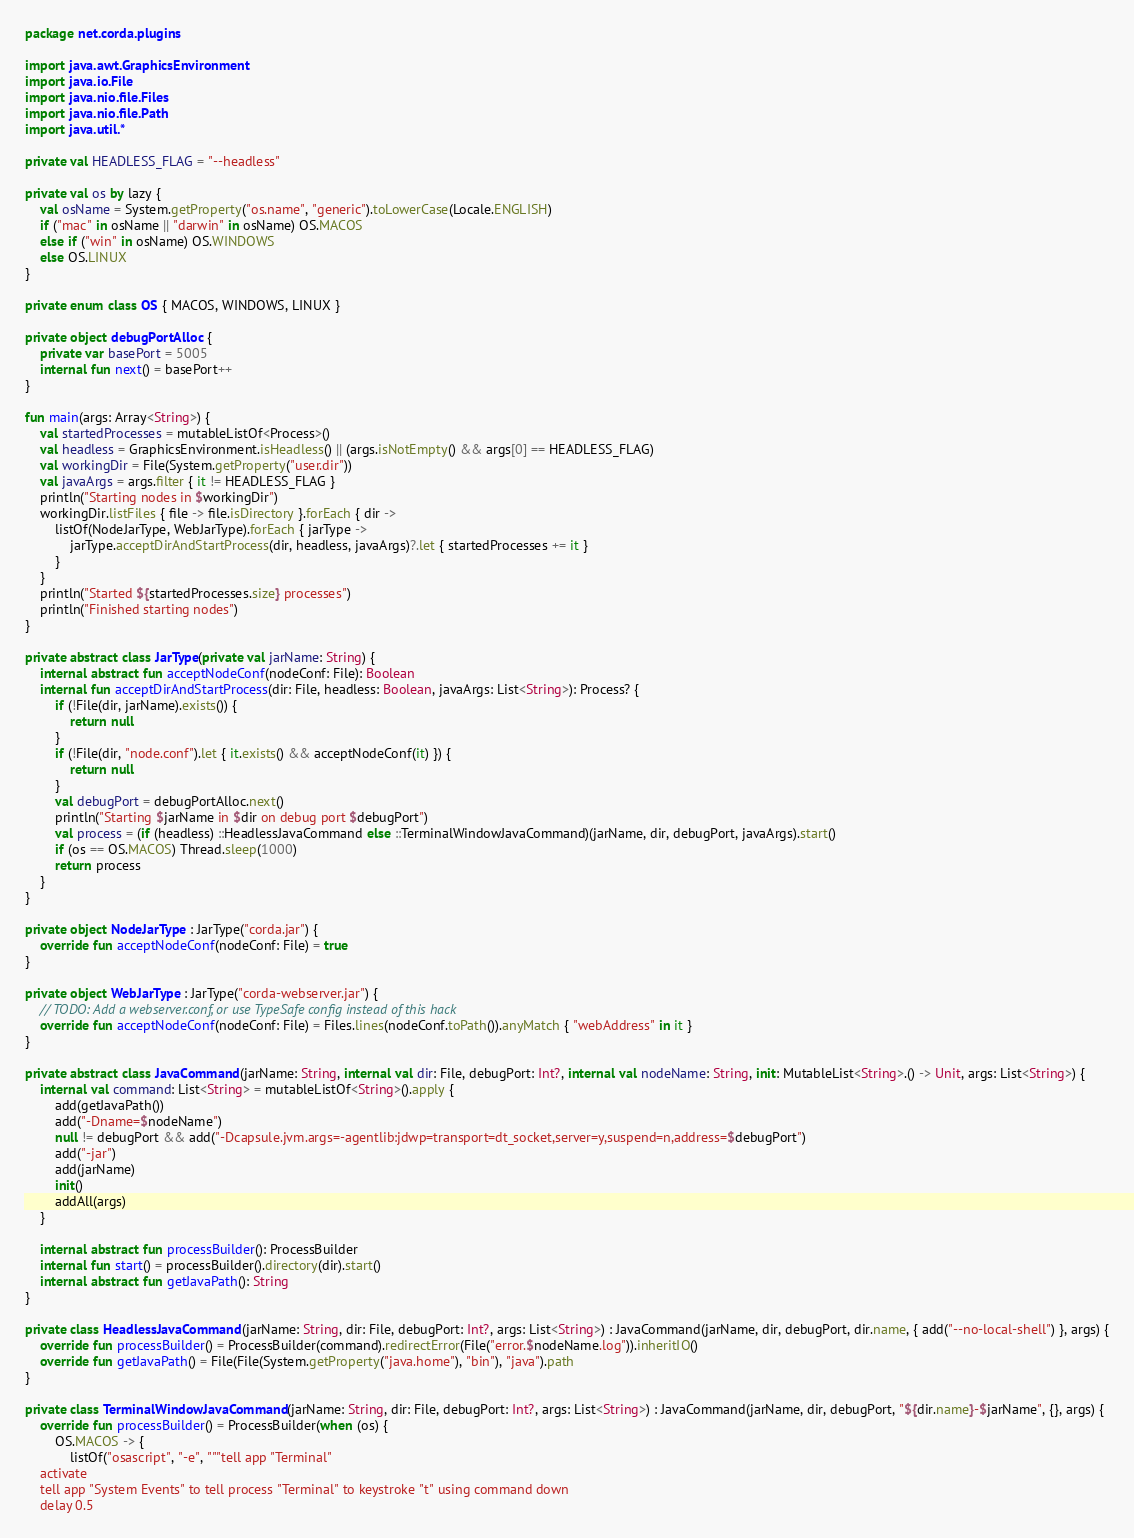<code> <loc_0><loc_0><loc_500><loc_500><_Kotlin_>package net.corda.plugins

import java.awt.GraphicsEnvironment
import java.io.File
import java.nio.file.Files
import java.nio.file.Path
import java.util.*

private val HEADLESS_FLAG = "--headless"

private val os by lazy {
    val osName = System.getProperty("os.name", "generic").toLowerCase(Locale.ENGLISH)
    if ("mac" in osName || "darwin" in osName) OS.MACOS
    else if ("win" in osName) OS.WINDOWS
    else OS.LINUX
}

private enum class OS { MACOS, WINDOWS, LINUX }

private object debugPortAlloc {
    private var basePort = 5005
    internal fun next() = basePort++
}

fun main(args: Array<String>) {
    val startedProcesses = mutableListOf<Process>()
    val headless = GraphicsEnvironment.isHeadless() || (args.isNotEmpty() && args[0] == HEADLESS_FLAG)
    val workingDir = File(System.getProperty("user.dir"))
    val javaArgs = args.filter { it != HEADLESS_FLAG }
    println("Starting nodes in $workingDir")
    workingDir.listFiles { file -> file.isDirectory }.forEach { dir ->
        listOf(NodeJarType, WebJarType).forEach { jarType ->
            jarType.acceptDirAndStartProcess(dir, headless, javaArgs)?.let { startedProcesses += it }
        }
    }
    println("Started ${startedProcesses.size} processes")
    println("Finished starting nodes")
}

private abstract class JarType(private val jarName: String) {
    internal abstract fun acceptNodeConf(nodeConf: File): Boolean
    internal fun acceptDirAndStartProcess(dir: File, headless: Boolean, javaArgs: List<String>): Process? {
        if (!File(dir, jarName).exists()) {
            return null
        }
        if (!File(dir, "node.conf").let { it.exists() && acceptNodeConf(it) }) {
            return null
        }
        val debugPort = debugPortAlloc.next()
        println("Starting $jarName in $dir on debug port $debugPort")
        val process = (if (headless) ::HeadlessJavaCommand else ::TerminalWindowJavaCommand)(jarName, dir, debugPort, javaArgs).start()
        if (os == OS.MACOS) Thread.sleep(1000)
        return process
    }
}

private object NodeJarType : JarType("corda.jar") {
    override fun acceptNodeConf(nodeConf: File) = true
}

private object WebJarType : JarType("corda-webserver.jar") {
    // TODO: Add a webserver.conf, or use TypeSafe config instead of this hack
    override fun acceptNodeConf(nodeConf: File) = Files.lines(nodeConf.toPath()).anyMatch { "webAddress" in it }
}

private abstract class JavaCommand(jarName: String, internal val dir: File, debugPort: Int?, internal val nodeName: String, init: MutableList<String>.() -> Unit, args: List<String>) {
    internal val command: List<String> = mutableListOf<String>().apply {
        add(getJavaPath())
        add("-Dname=$nodeName")
        null != debugPort && add("-Dcapsule.jvm.args=-agentlib:jdwp=transport=dt_socket,server=y,suspend=n,address=$debugPort")
        add("-jar")
        add(jarName)
        init()
        addAll(args)
    }

    internal abstract fun processBuilder(): ProcessBuilder
    internal fun start() = processBuilder().directory(dir).start()
    internal abstract fun getJavaPath(): String
}

private class HeadlessJavaCommand(jarName: String, dir: File, debugPort: Int?, args: List<String>) : JavaCommand(jarName, dir, debugPort, dir.name, { add("--no-local-shell") }, args) {
    override fun processBuilder() = ProcessBuilder(command).redirectError(File("error.$nodeName.log")).inheritIO()
    override fun getJavaPath() = File(File(System.getProperty("java.home"), "bin"), "java").path
}

private class TerminalWindowJavaCommand(jarName: String, dir: File, debugPort: Int?, args: List<String>) : JavaCommand(jarName, dir, debugPort, "${dir.name}-$jarName", {}, args) {
    override fun processBuilder() = ProcessBuilder(when (os) {
        OS.MACOS -> {
            listOf("osascript", "-e", """tell app "Terminal"
    activate
    tell app "System Events" to tell process "Terminal" to keystroke "t" using command down
    delay 0.5</code> 